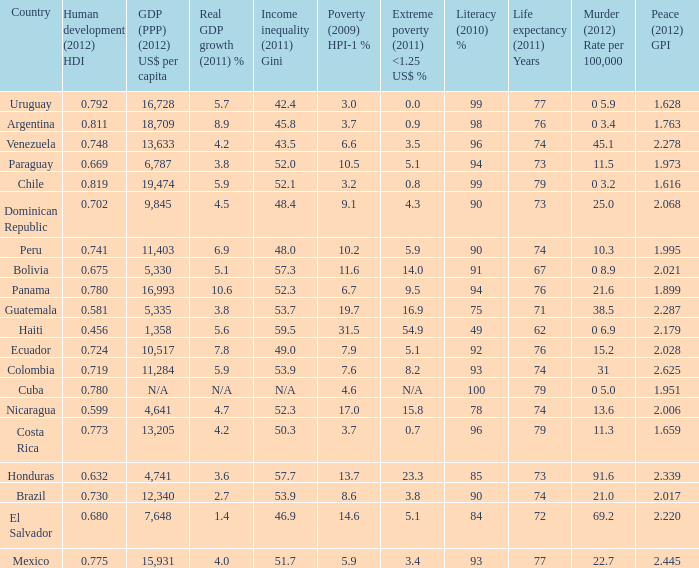What is the sum of poverty (2009) HPI-1 % when the GDP (PPP) (2012) US$ per capita of 11,284? 1.0. 